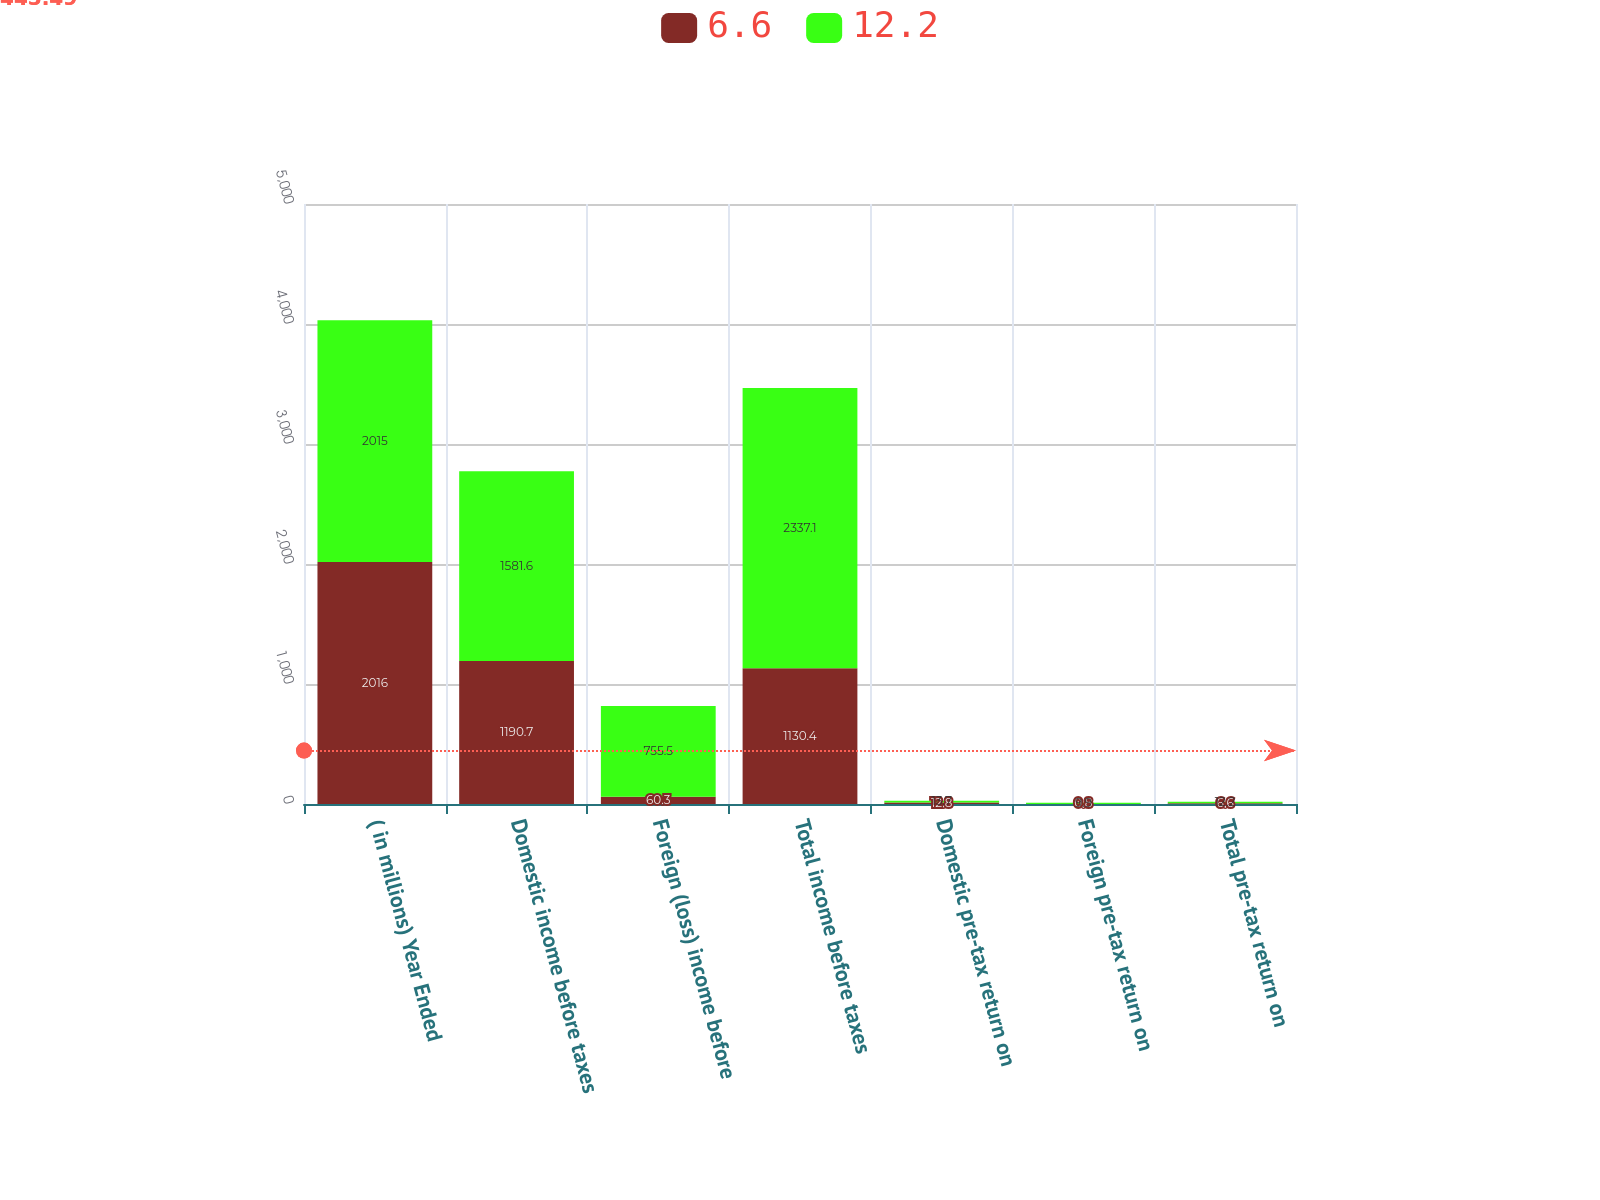<chart> <loc_0><loc_0><loc_500><loc_500><stacked_bar_chart><ecel><fcel>( in millions) Year Ended<fcel>Domestic income before taxes<fcel>Foreign (loss) income before<fcel>Total income before taxes<fcel>Domestic pre-tax return on<fcel>Foreign pre-tax return on<fcel>Total pre-tax return on<nl><fcel>6.6<fcel>2016<fcel>1190.7<fcel>60.3<fcel>1130.4<fcel>12.8<fcel>0.8<fcel>6.6<nl><fcel>12.2<fcel>2015<fcel>1581.6<fcel>755.5<fcel>2337.1<fcel>13.7<fcel>9.9<fcel>12.2<nl></chart> 